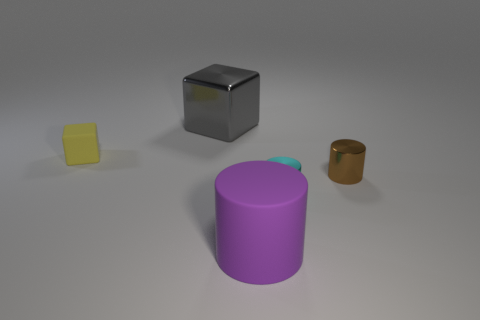Subtract all small cyan cylinders. How many cylinders are left? 2 Subtract all gray blocks. How many blocks are left? 1 Subtract 2 cylinders. How many cylinders are left? 1 Add 1 small matte things. How many objects exist? 6 Subtract all cubes. How many objects are left? 3 Subtract 0 purple cubes. How many objects are left? 5 Subtract all purple cubes. Subtract all yellow spheres. How many cubes are left? 2 Subtract all cyan cubes. How many cyan cylinders are left? 1 Subtract all red matte spheres. Subtract all large objects. How many objects are left? 3 Add 5 shiny things. How many shiny things are left? 8 